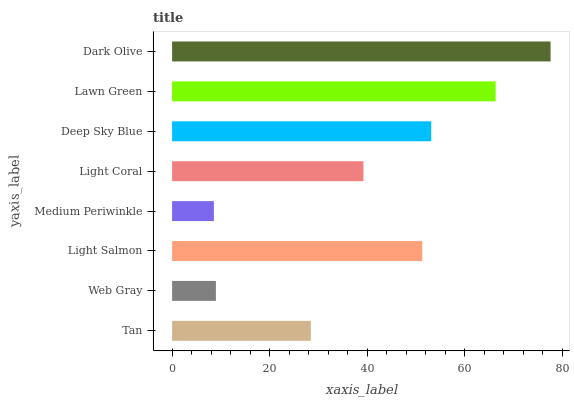Is Medium Periwinkle the minimum?
Answer yes or no. Yes. Is Dark Olive the maximum?
Answer yes or no. Yes. Is Web Gray the minimum?
Answer yes or no. No. Is Web Gray the maximum?
Answer yes or no. No. Is Tan greater than Web Gray?
Answer yes or no. Yes. Is Web Gray less than Tan?
Answer yes or no. Yes. Is Web Gray greater than Tan?
Answer yes or no. No. Is Tan less than Web Gray?
Answer yes or no. No. Is Light Salmon the high median?
Answer yes or no. Yes. Is Light Coral the low median?
Answer yes or no. Yes. Is Tan the high median?
Answer yes or no. No. Is Lawn Green the low median?
Answer yes or no. No. 